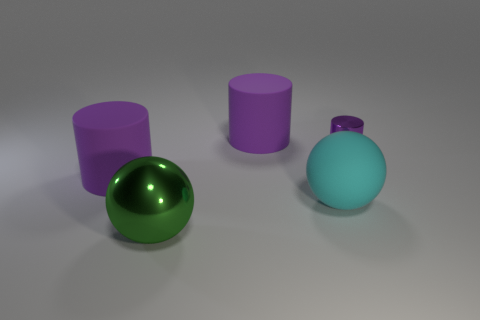Is the number of big purple cylinders that are to the right of the cyan sphere less than the number of green shiny objects? yes 